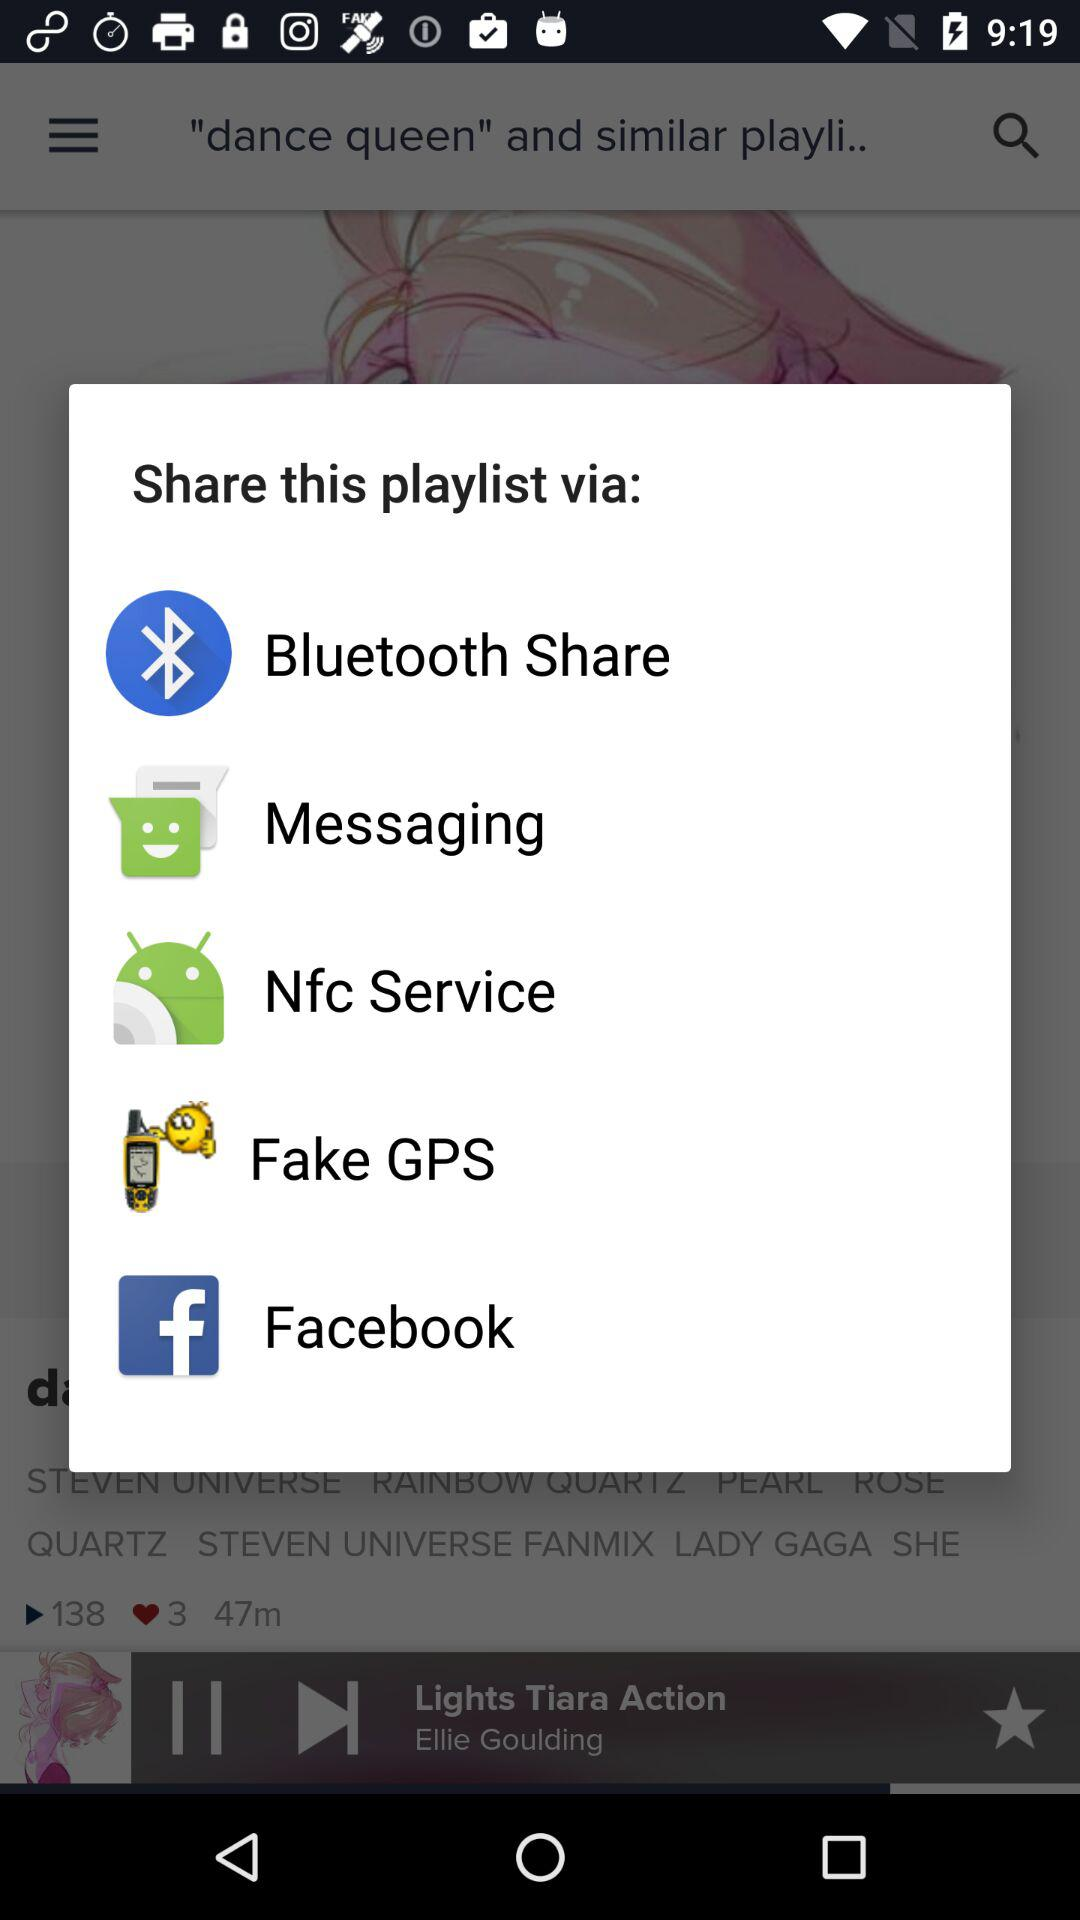Through which application can we share the playlist? You can share the playlist through "Bluetooth Share", "Messaging", "Nfc Service", "Fake GPS" and "Facebook". 